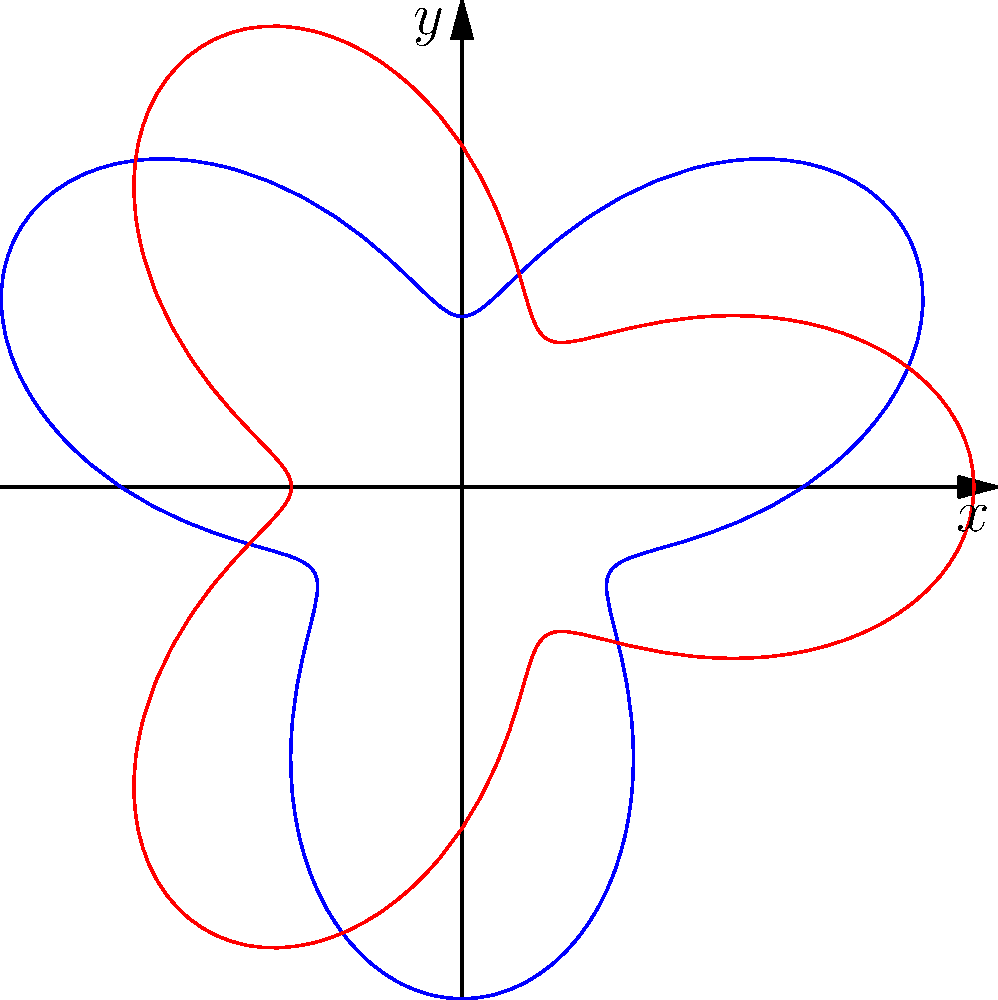Analyzing the polar graph of tension release patterns, which function, $r = 2 + \sin(3\theta)$ (blue) or $r = 2 + \cos(3\theta)$ (red), exhibits perfect symmetry about both the x-axis and y-axis? To determine which function exhibits perfect symmetry about both the x-axis and y-axis, we need to analyze the properties of sine and cosine functions in polar form:

1. For $r = 2 + \sin(3\theta)$ (blue curve):
   - Symmetric about the y-axis: Yes, because $\sin(-\theta) = -\sin(\theta)$
   - Symmetric about the x-axis: No, because $\sin(\pi - \theta) \neq \sin(\theta)$

2. For $r = 2 + \cos(3\theta)$ (red curve):
   - Symmetric about the x-axis: Yes, because $\cos(-\theta) = \cos(\theta)$
   - Symmetric about the y-axis: Yes, because $\cos(\pi - \theta) = -\cos(\theta)$

The cosine function in polar form creates a graph that is symmetric about both axes due to its even function properties. The sine function, however, only exhibits symmetry about the y-axis due to its odd function properties.

Therefore, the red curve representing $r = 2 + \cos(3\theta)$ exhibits perfect symmetry about both the x-axis and y-axis.
Answer: $r = 2 + \cos(3\theta)$ (red curve) 